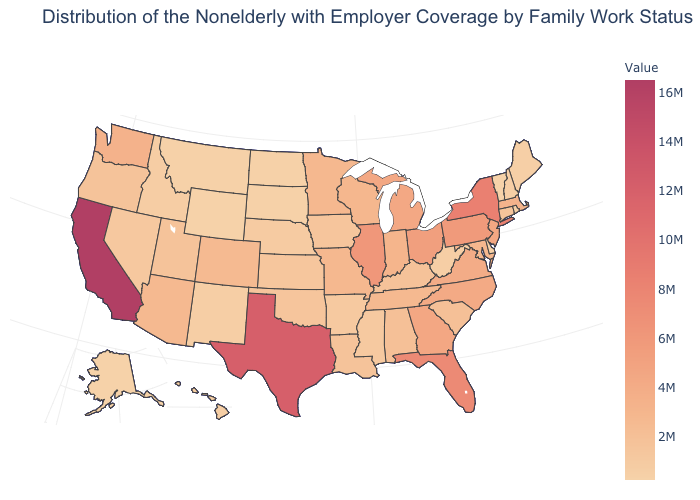Which states have the lowest value in the USA?
Write a very short answer. Vermont. Which states hav the highest value in the MidWest?
Be succinct. Illinois. Among the states that border Illinois , which have the lowest value?
Give a very brief answer. Iowa. Does Nebraska have the lowest value in the USA?
Keep it brief. No. 